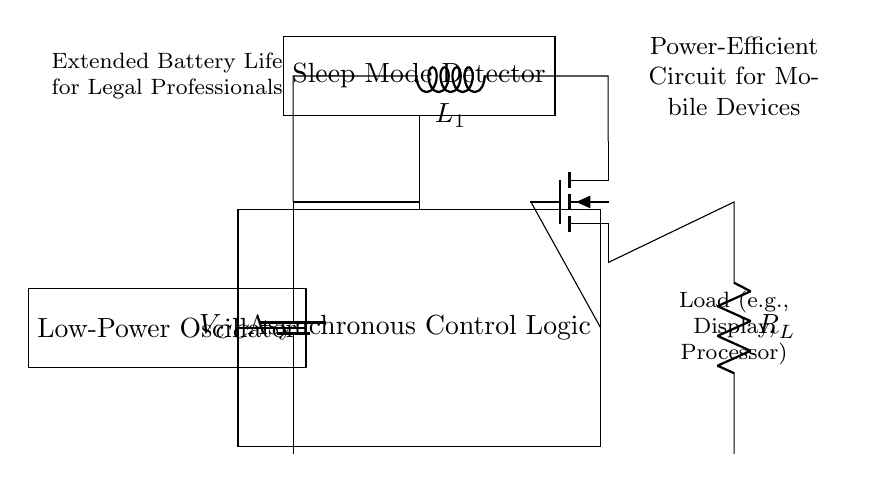What is the main purpose of the asynchronous control logic? The asynchronous control logic manages the circuit's operations, enabling power-saving features and efficient control of the load based on input signals.
Answer: Manage power-saving features What component is represented by "R_L" in the circuit? "R_L" denotes the load resistor, which represents the components of the circuit that consume electrical power, such as a display or processor.
Answer: Load resistor How does the sleep mode detector affect circuit operation? The sleep mode detector monitors the state of the device and signals the control logic to enter low-power states when the device is not active, helping conserve battery life.
Answer: Conserves battery life What is the function of the low-power oscillator in the circuit? The low-power oscillator generates clock signals for enabling the operation of other components while consuming minimal power, crucial for extending battery life.
Answer: Generate clock signals How does the power gating transistor contribute to energy savings? The power gating transistor controls the flow of power to the load by disconnecting it when the device is in sleep mode, thereby significantly reducing energy consumption.
Answer: Disconnects power What does "V_CC" represent in this circuit? "V_CC" indicates the voltage supply for the circuit, typically necessary for powering active components like the transistor and logic circuitry in operation.
Answer: Voltage supply What is the significance of extended battery life in mobile devices for legal professionals? Extended battery life is crucial for legal professionals who often work long hours and need reliable devices that do not fail due to low battery during critical tasks such as court sessions or client meetings.
Answer: Reliability during critical tasks 